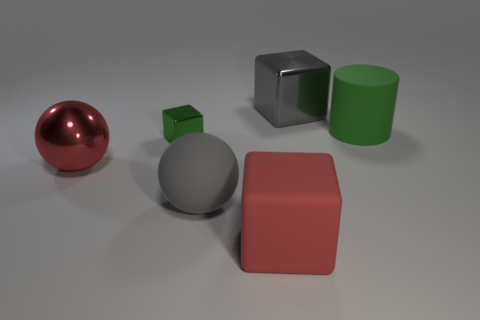There is a metallic thing that is the same color as the rubber cube; what is its shape?
Your answer should be compact. Sphere. How many shiny objects are either brown things or gray cubes?
Your answer should be compact. 1. How many big objects are both to the right of the large metal cube and left of the tiny green cube?
Offer a very short reply. 0. Is there anything else that is the same shape as the big green thing?
Provide a short and direct response. No. What number of other things are the same size as the red rubber object?
Provide a short and direct response. 4. Is the size of the red thing behind the large gray rubber ball the same as the gray thing that is behind the big green rubber cylinder?
Make the answer very short. Yes. What number of objects are green matte balls or shiny cubes that are in front of the gray cube?
Your answer should be compact. 1. What size is the cube on the left side of the big red block?
Your response must be concise. Small. Is the number of small cubes right of the large red rubber block less than the number of gray objects that are left of the small cube?
Provide a short and direct response. No. There is a block that is in front of the gray metallic thing and behind the red matte cube; what material is it?
Offer a terse response. Metal. 